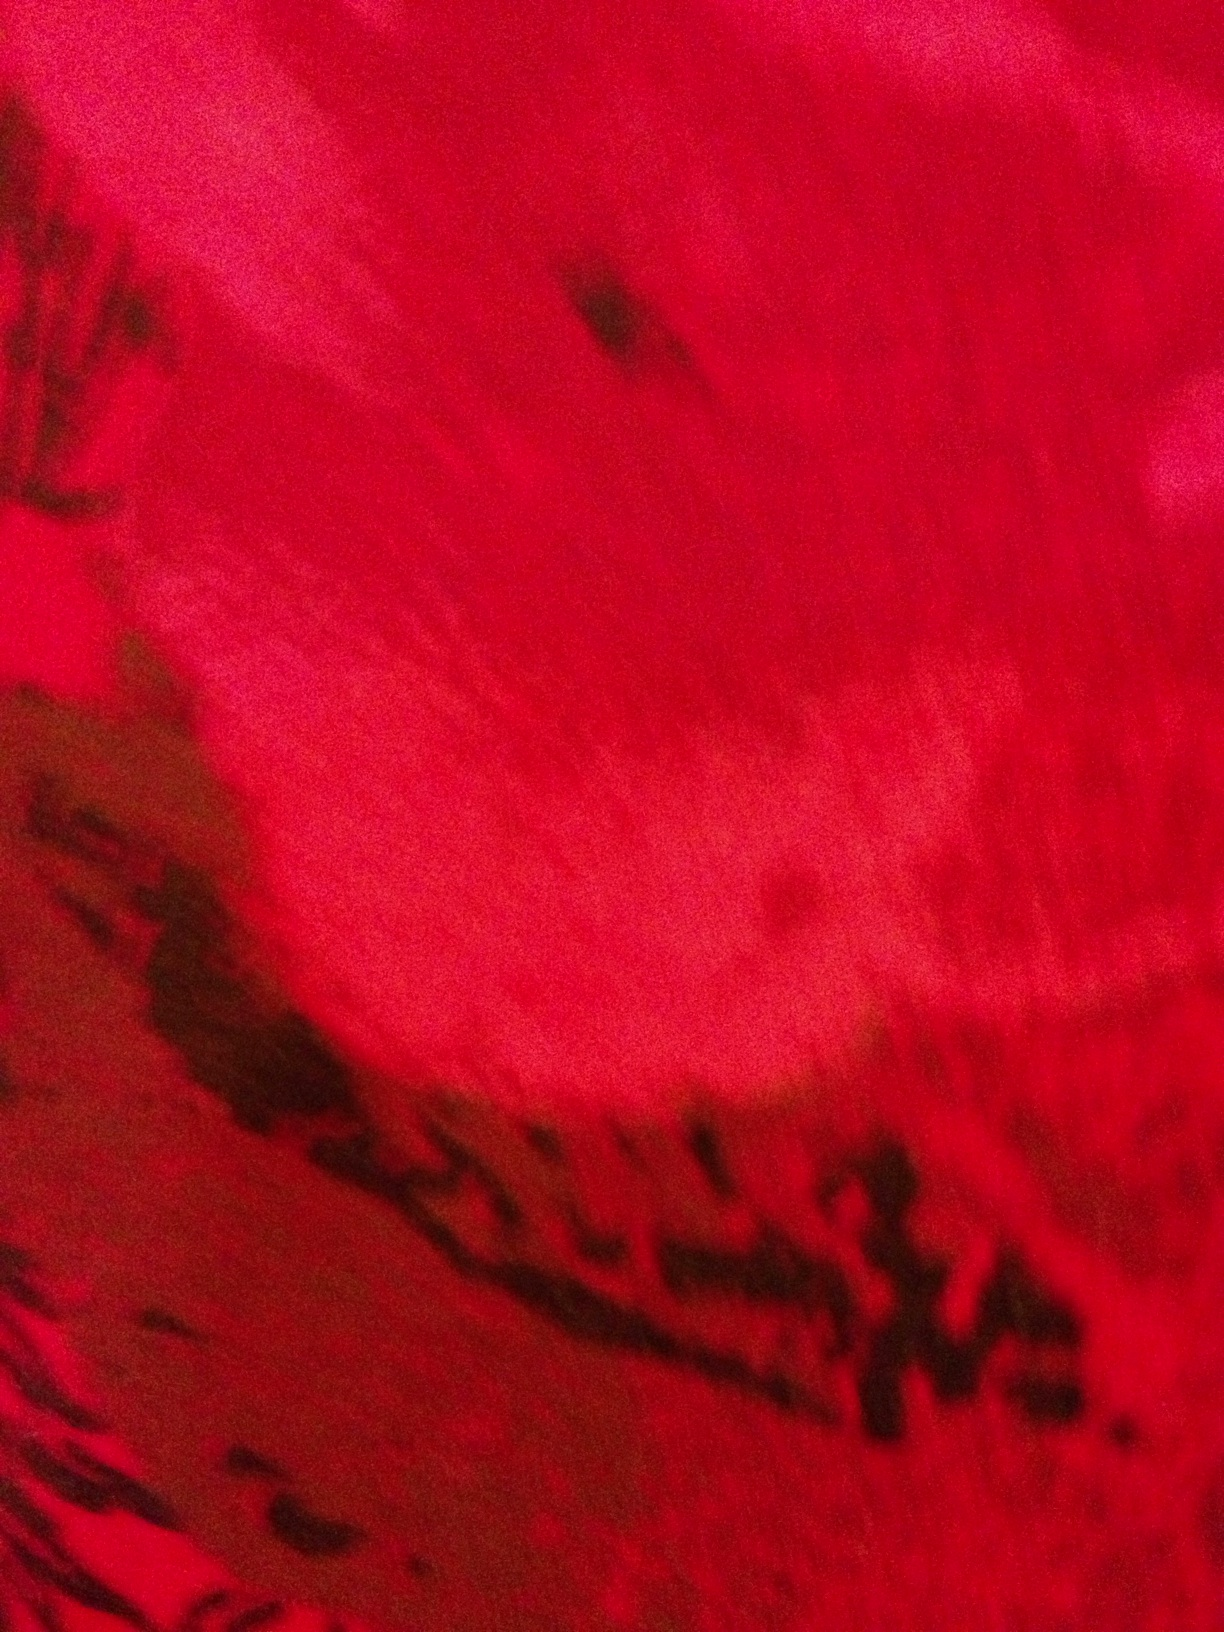Imagine if this red surface was on another planet. Describe what kind of planet it might be. This image could depict the surface of an alien planet named Veridia Prime, known for its breathtaking red landscapes. The ground is covered in a unique crystalline substance that glows faintly under the twin suns, creating a mesmerizing vista. The planet is rich in rare minerals, attracting explorers and scientists from across the galaxy. What kind of creatures might inhabit Veridia Prime? Veridia Prime is home to a variety of extraordinary creatures. The most notable are the Veridian Phoenixes, magnificent birds with plumage as red as the planet's surface, their feathers shimmering in the sunlight. There are also bioluminescent insects that create dazzling light shows at night, and ancient, sentient beings known as the Eldertree Guardians, who protect the delicate balance of the planet's ecosystems. Write an extremely detailed description of a day in the life of a Veridian Phoenix. The Veridian Phoenix begins its day at dawn, as the first of the twin suns rises over the horizon, bathing the crimson landscape in golden light. The Phoenix, perched atop a towering crystal spire, stretches its brilliant wings, catching the light and causing a dazzling display of colors to ripple through the air. It launches into flight, soaring high above the ground, scanning the terrain below for signs of its morning meal—a rare and elusive species of crystal beetle that burrows beneath the surface. The Phoenix dives gracefully, its keen eyesight pinpointing the slightest movement. With a swift and precise motion, it captures its prey, basking in the satisfaction of a successful hunt. As the second sun ascends, adding to the warmth and light, the Phoenix engages in a mid-morning ritual of preening its feathers, ensuring they remain in pristine condition. This ritual is observed by other creatures, who believe it brings them good fortune. Throughout the day, the Phoenix explores its territory, a vast expanse of crystalline forests and sparkling lakes, interacting with other Phoenixes through a series of melodic calls that echo across the landscape. These interactions are vital, fostering a deep sense of community and ensuring the survival of their species. As evening approaches and the skies are painted with hues of red and orange, the Phoenix returns to its roost, a nest of intricately woven crystal strands, where it will rest and rejuvenate. Nightfall brings the cool glow of the bioluminescent insects, and the Phoenix, now in a state of repose, watches the mesmerizing dance of lights, a nightly spectacle that lulls it into a peaceful sleep, ready to begin again with the dawn. 